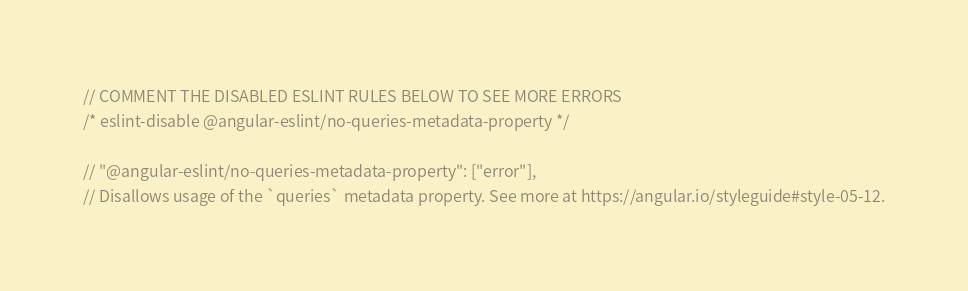<code> <loc_0><loc_0><loc_500><loc_500><_TypeScript_>// COMMENT THE DISABLED ESLINT RULES BELOW TO SEE MORE ERRORS
/* eslint-disable @angular-eslint/no-queries-metadata-property */

// "@angular-eslint/no-queries-metadata-property": ["error"],
// Disallows usage of the `queries` metadata property. See more at https://angular.io/styleguide#style-05-12.
</code> 